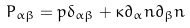<formula> <loc_0><loc_0><loc_500><loc_500>P _ { \alpha \beta } = p \delta _ { \alpha \beta } + \kappa \partial _ { \alpha } n \partial _ { \beta } n</formula> 